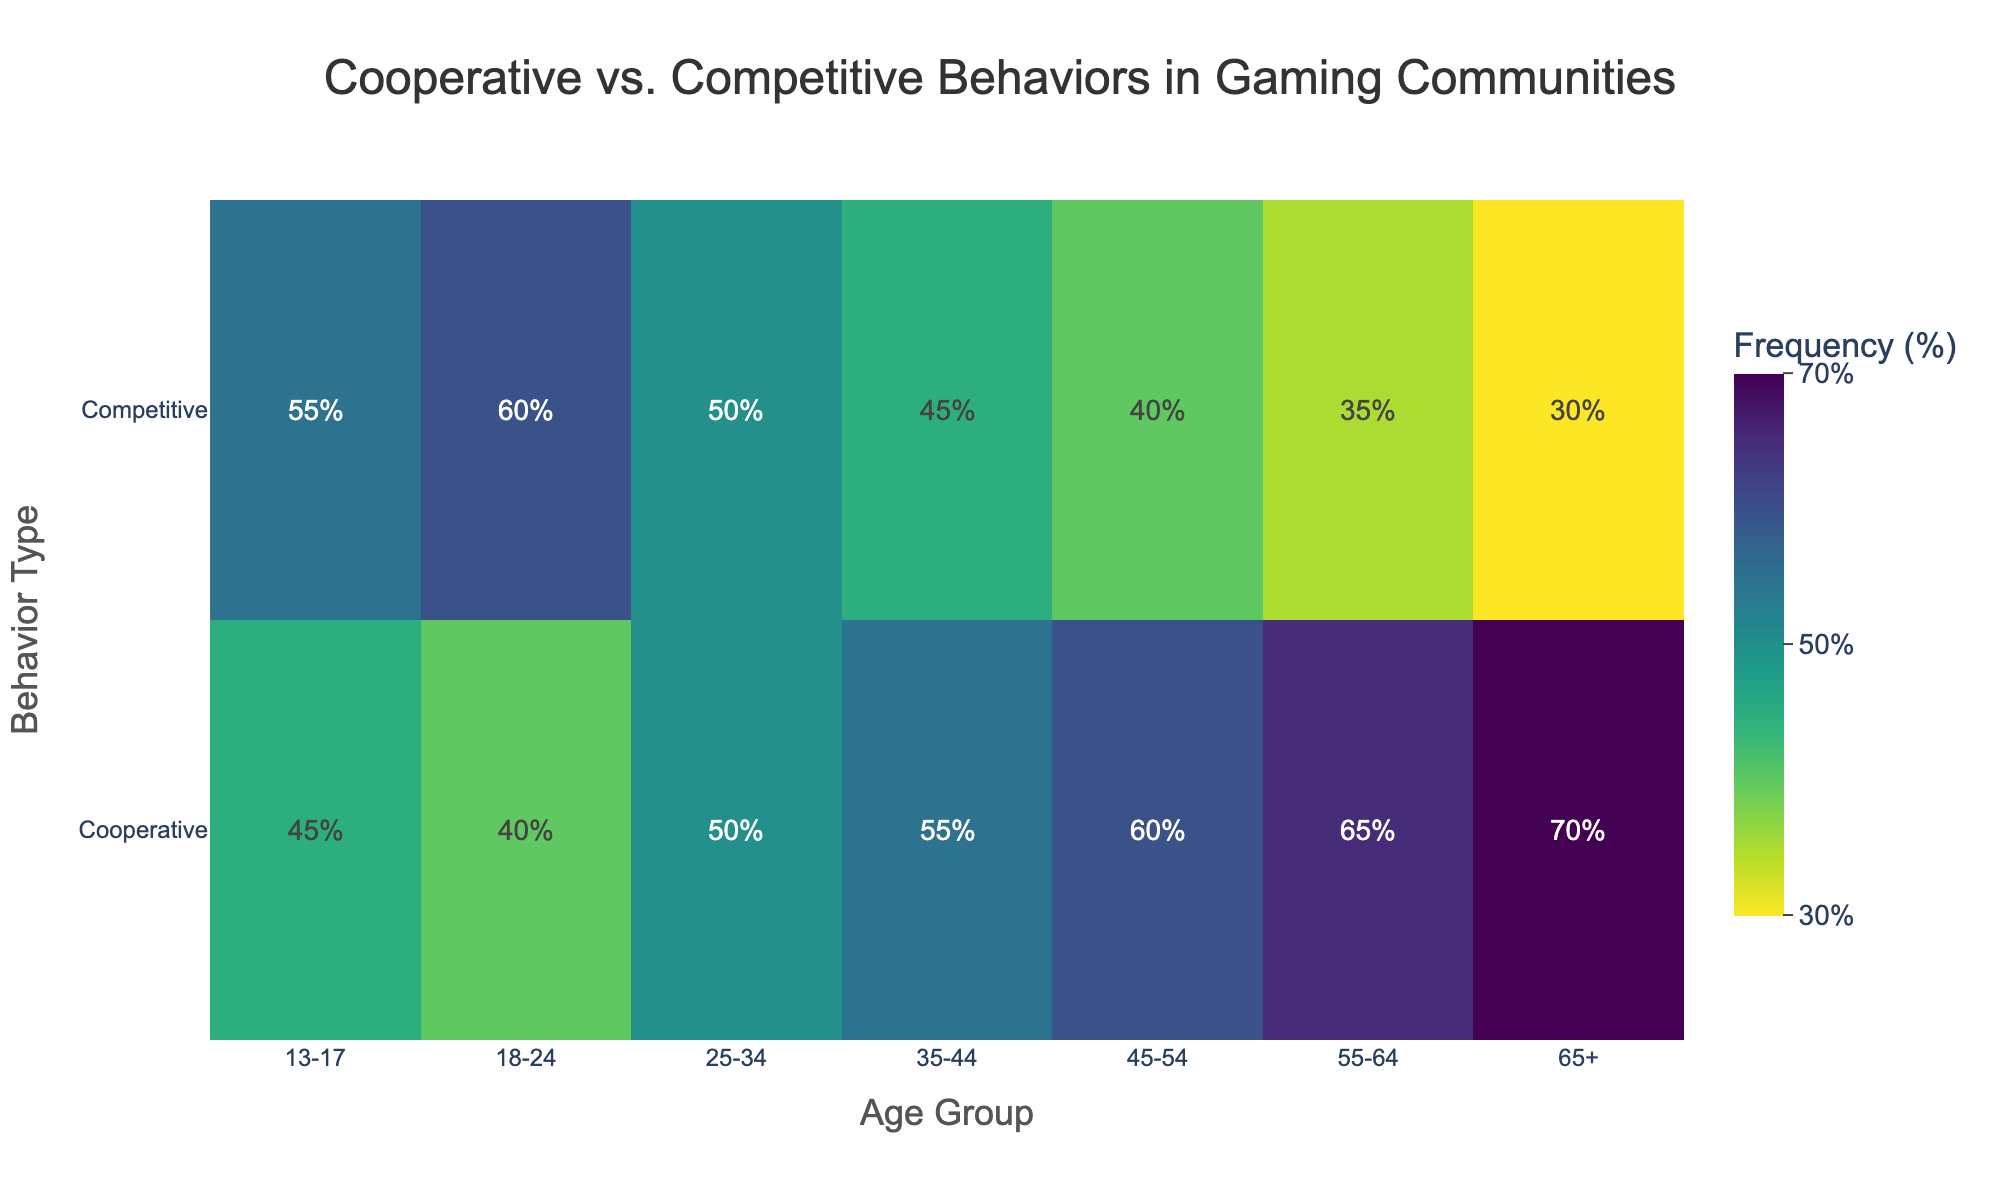what is the title of the heatmap? The title of the heatmap is located at the top center of the figure and it reads "Cooperative vs. Competitive Behaviors in Gaming Communities".
Answer: Cooperative vs. Competitive Behaviors in Gaming Communities What is the age group with the highest cooperative frequency? The heatmap indicates cooperative frequencies per age group in the top row. The age group '65+' has the highest frequency at 70%.
Answer: 65+ Which age group has an equal frequency of cooperative and competitive behaviors? The frequencies for cooperative and competitive behaviors are shown in parallel. For the age group '25-34', both frequencies are 50%.
Answer: 25-34 What's the difference in competitive frequency between age groups 13-17 and 65+? To get the difference, subtract the competitive frequency of the 65+ age group (30%) from the competitive frequency of the 13-17 age group (55%).
Answer: 25% What age group shows the least competitive behavior? The competitive frequencies are displayed in the bottom row. The age group '65+' has the lowest competitive frequency at 30%.
Answer: 65+ Which frequency value is more common in the heatmap, 45% or 50%? By observing the heatmap, 45% appears twice (in competitive frequencies for 35-44 and 25-34) while 50% appears once (in cooperative frequency for 25-34). Therefore, 45% is more common.
Answer: 45% How does the cooperative frequency trend change with age? As the age groups progress from '13-17' to '65+', there is a visible increase in cooperative frequency, starting at 45% and peaking at 70%.
Answer: Increases What is the average competitive frequency across all age groups? Add the competitive frequencies (55, 60, 50, 45, 40, 35, 30) and divide by the number of age groups (7): (55 + 60 + 50 + 45 + 40 + 35 + 30) / 7 = 315 / 7 = 45%.
Answer: 45% Which behavior type is generally more dominant in younger age groups? By comparing the heatmap values for cooperative and competitive behaviors in age groups '13-17' and '18-24', the competitive behavior frequencies (55% and 60%) are higher than cooperative frequencies for those groups.
Answer: Competitive What is the cooperative frequency for the age group '55-64'? By looking at the heatmap, for the age group '55-64', the cooperative frequency is 65%.
Answer: 65% 